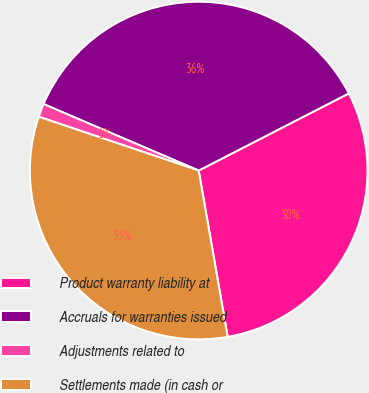Convert chart to OTSL. <chart><loc_0><loc_0><loc_500><loc_500><pie_chart><fcel>Product warranty liability at<fcel>Accruals for warranties issued<fcel>Adjustments related to<fcel>Settlements made (in cash or<nl><fcel>29.81%<fcel>36.0%<fcel>1.28%<fcel>32.91%<nl></chart> 